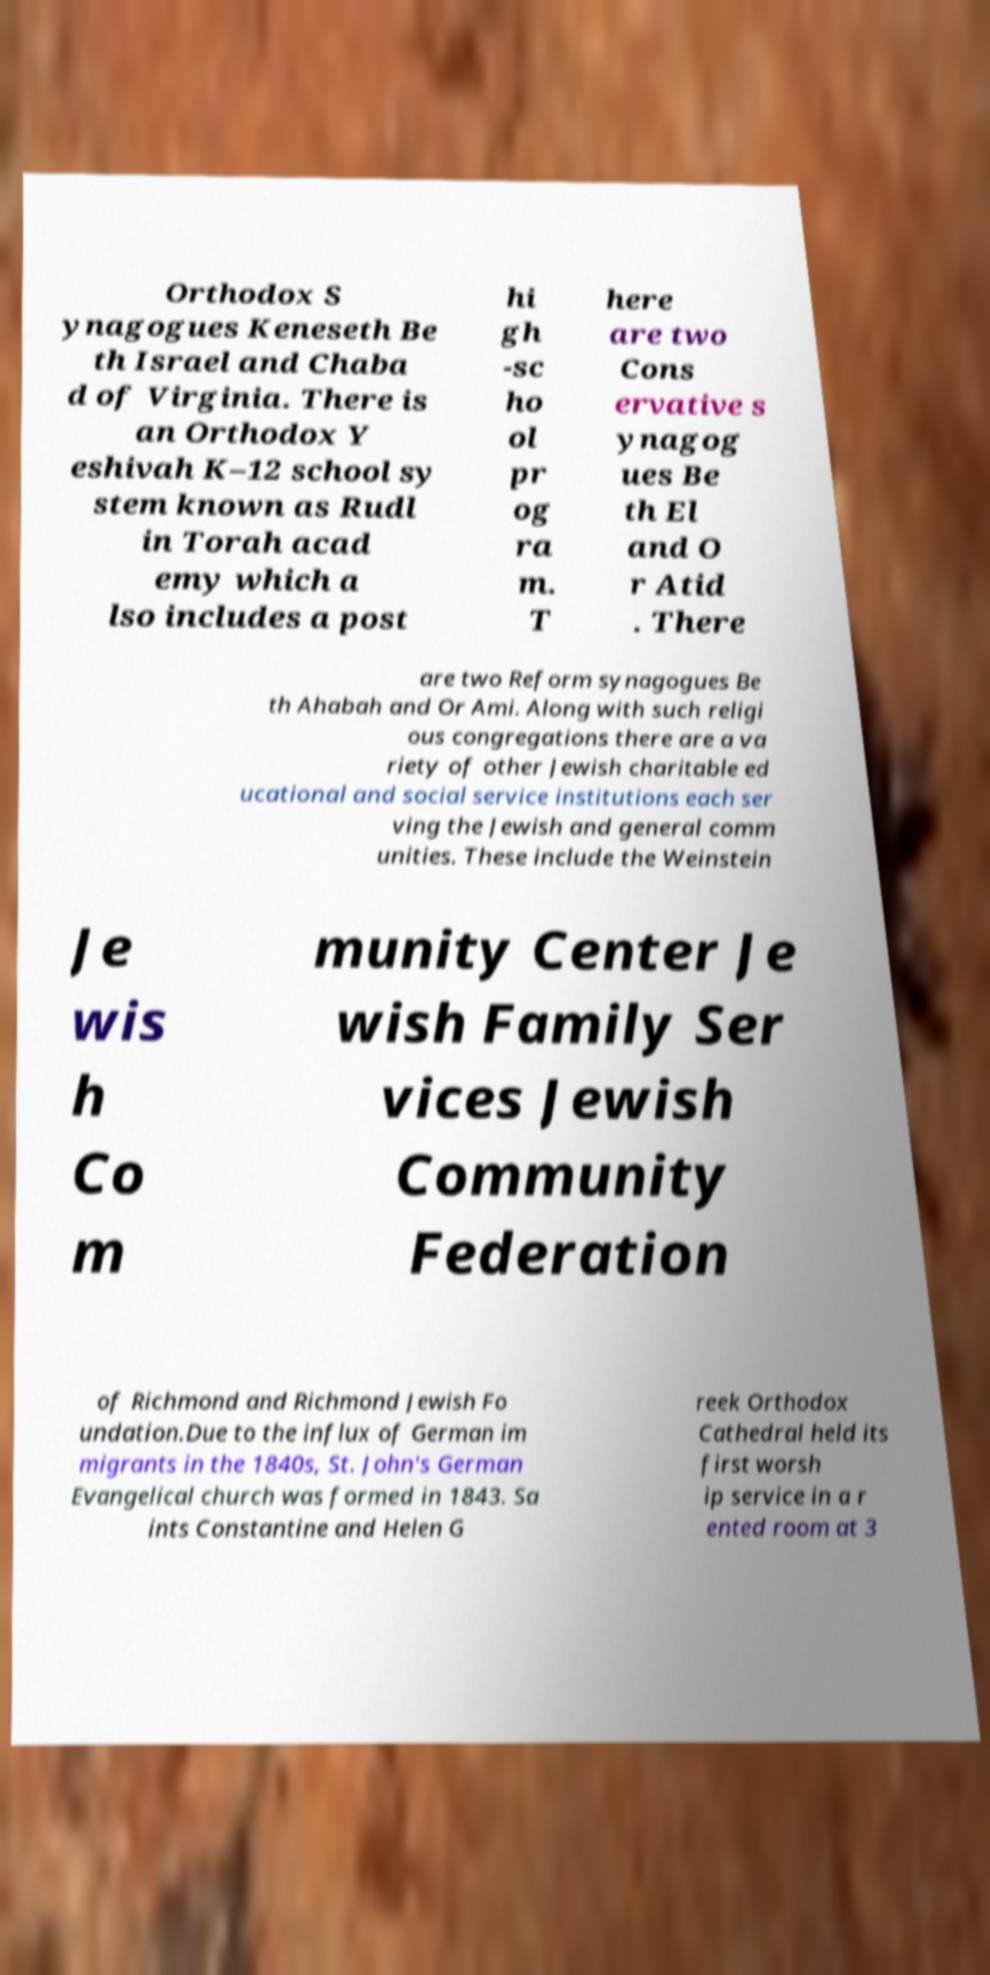Can you read and provide the text displayed in the image?This photo seems to have some interesting text. Can you extract and type it out for me? Orthodox S ynagogues Keneseth Be th Israel and Chaba d of Virginia. There is an Orthodox Y eshivah K–12 school sy stem known as Rudl in Torah acad emy which a lso includes a post hi gh -sc ho ol pr og ra m. T here are two Cons ervative s ynagog ues Be th El and O r Atid . There are two Reform synagogues Be th Ahabah and Or Ami. Along with such religi ous congregations there are a va riety of other Jewish charitable ed ucational and social service institutions each ser ving the Jewish and general comm unities. These include the Weinstein Je wis h Co m munity Center Je wish Family Ser vices Jewish Community Federation of Richmond and Richmond Jewish Fo undation.Due to the influx of German im migrants in the 1840s, St. John's German Evangelical church was formed in 1843. Sa ints Constantine and Helen G reek Orthodox Cathedral held its first worsh ip service in a r ented room at 3 